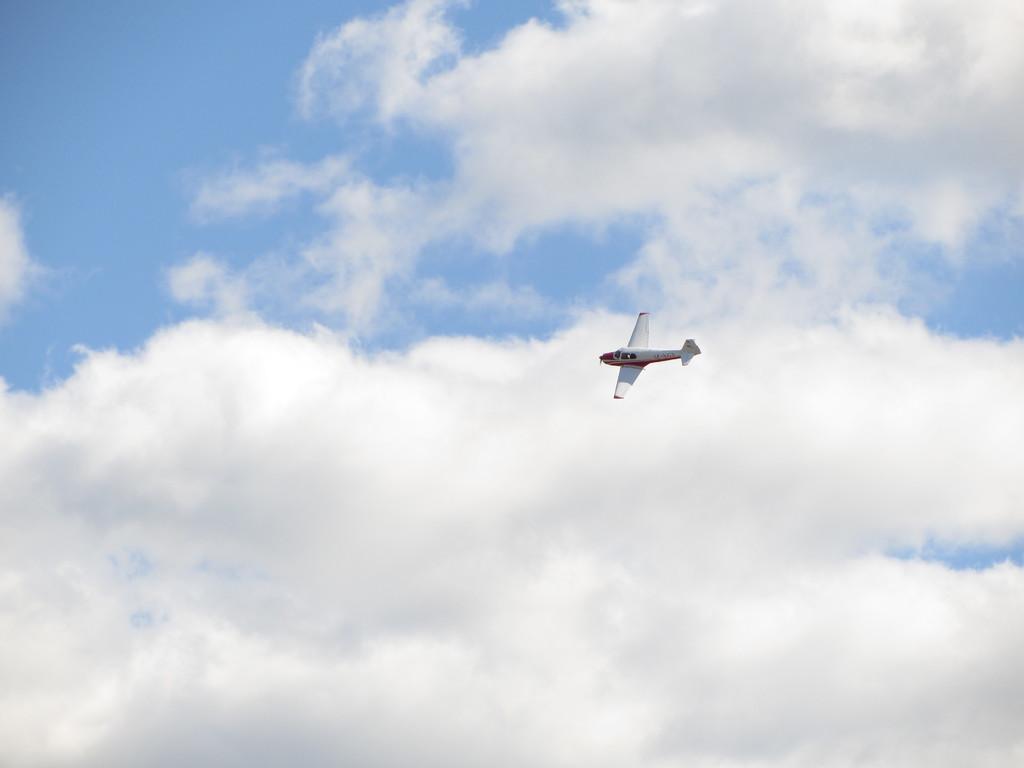Could you give a brief overview of what you see in this image? This picture is clicked outside. In the center we can see an airplane flying in the sky. In the background we can see the sky with the clouds. 